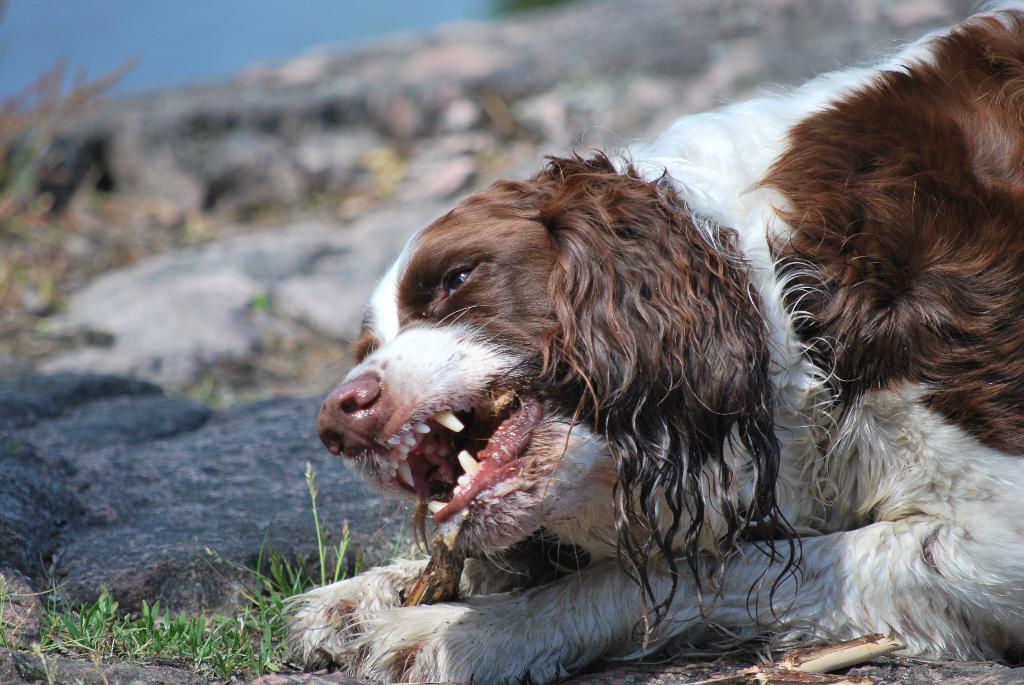Could you give a brief overview of what you see in this image? There is a dog lying on the ground as we can see on the right side of this image. It seems like there is a rock on the left side of this image. 